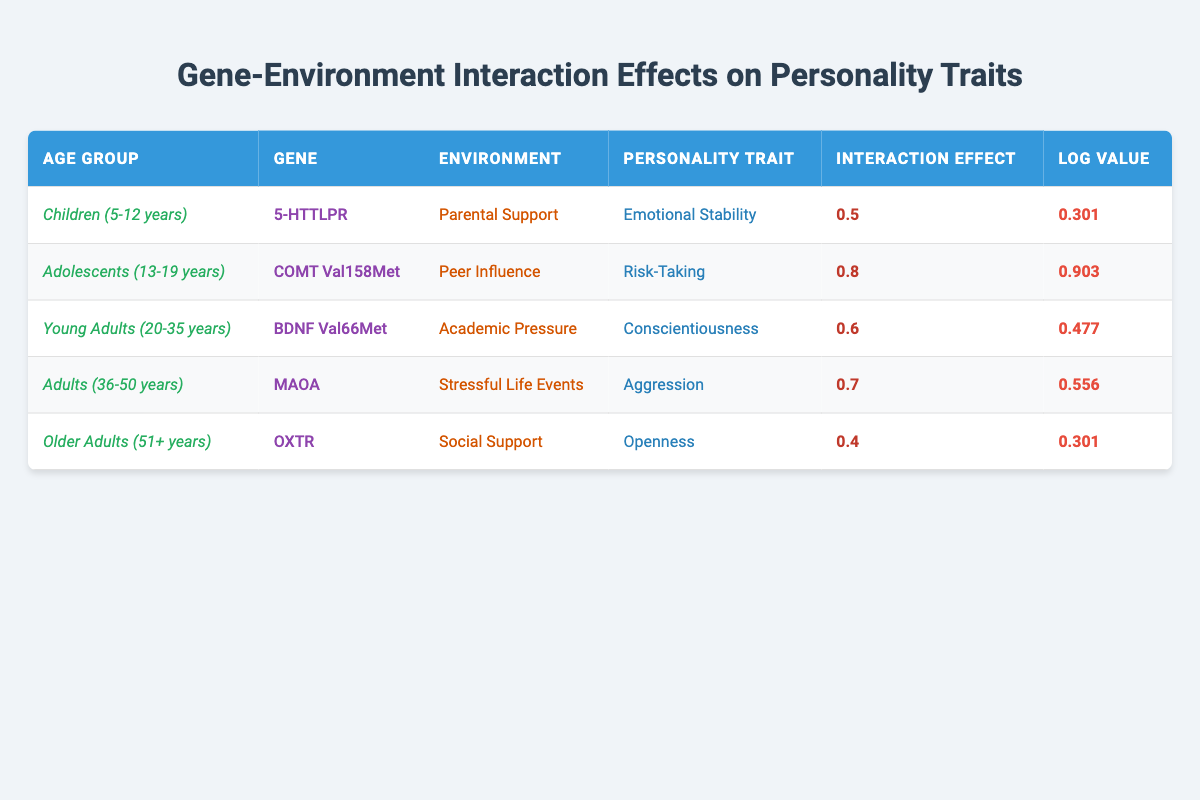What is the personality trait associated with the gene BDNF Val66Met in young adults? According to the table, the personality trait associated with the gene BDNF Val66Met, which belongs to the age group of young adults (20-35 years), is conscientiousness.
Answer: Conscientiousness Which age group shows the highest interaction effect with their environmental influence? In the table, the age group with the highest interaction effect is adolescents (13-19 years), with a value of 0.8 associated with peer influence on risk-taking.
Answer: Adolescents (13-19 years) What is the average interaction effect for the personality traits listed? To find the average interaction effect, sum all the interaction effects: 0.5 + 0.8 + 0.6 + 0.7 + 0.4 = 3.0. There are 5 data points, so the average is 3.0 / 5 = 0.6.
Answer: 0.6 Is the gene 5-HTTLPR associated with emotional stability in adults? The table shows that the gene 5-HTTLPR is associated with emotional stability in children (5-12 years) and not in adults. Therefore, the statement is false.
Answer: No Which age group and environmental influence combination leads to the lowest interaction effect, and what is that value? The lowest interaction effect is 0.4, associated with the age group of older adults (51+ years) and the environmental influence of social support.
Answer: Older Adults (51+ years) with Social Support, 0.4 What is the difference in interaction effects between young adults and adults? The interaction effect for young adults is 0.6, and for adults, it is 0.7. The difference is calculated by subtracting the two: 0.6 - 0.7 = -0.1.
Answer: -0.1 